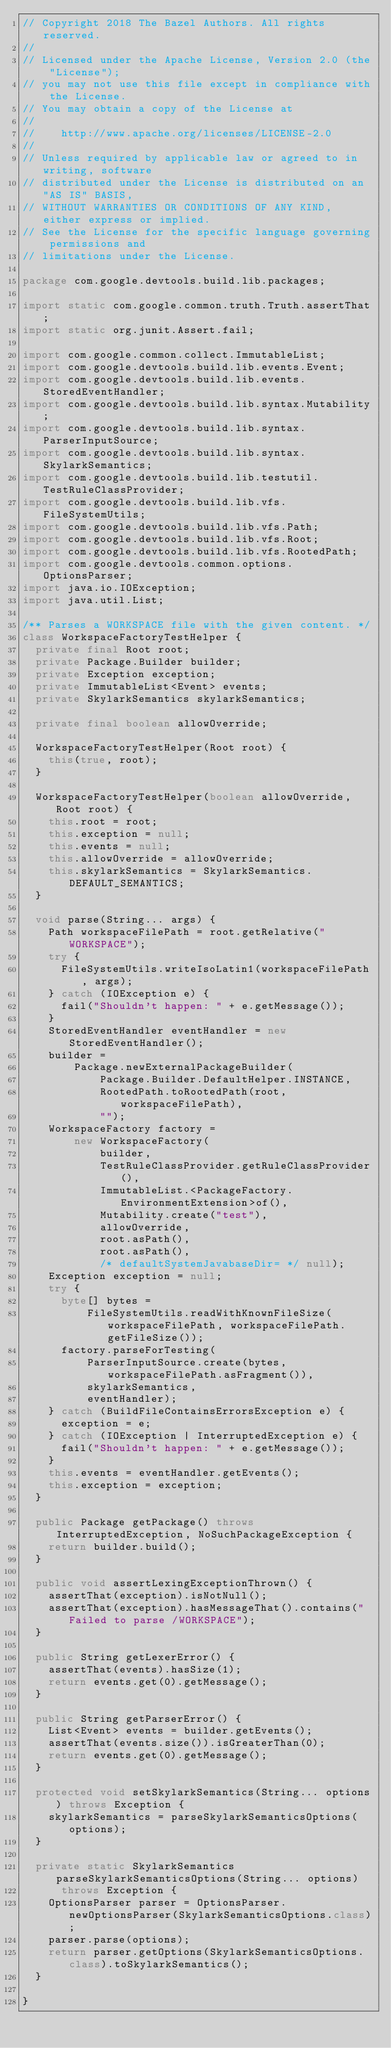<code> <loc_0><loc_0><loc_500><loc_500><_Java_>// Copyright 2018 The Bazel Authors. All rights reserved.
//
// Licensed under the Apache License, Version 2.0 (the "License");
// you may not use this file except in compliance with the License.
// You may obtain a copy of the License at
//
//    http://www.apache.org/licenses/LICENSE-2.0
//
// Unless required by applicable law or agreed to in writing, software
// distributed under the License is distributed on an "AS IS" BASIS,
// WITHOUT WARRANTIES OR CONDITIONS OF ANY KIND, either express or implied.
// See the License for the specific language governing permissions and
// limitations under the License.

package com.google.devtools.build.lib.packages;

import static com.google.common.truth.Truth.assertThat;
import static org.junit.Assert.fail;

import com.google.common.collect.ImmutableList;
import com.google.devtools.build.lib.events.Event;
import com.google.devtools.build.lib.events.StoredEventHandler;
import com.google.devtools.build.lib.syntax.Mutability;
import com.google.devtools.build.lib.syntax.ParserInputSource;
import com.google.devtools.build.lib.syntax.SkylarkSemantics;
import com.google.devtools.build.lib.testutil.TestRuleClassProvider;
import com.google.devtools.build.lib.vfs.FileSystemUtils;
import com.google.devtools.build.lib.vfs.Path;
import com.google.devtools.build.lib.vfs.Root;
import com.google.devtools.build.lib.vfs.RootedPath;
import com.google.devtools.common.options.OptionsParser;
import java.io.IOException;
import java.util.List;

/** Parses a WORKSPACE file with the given content. */
class WorkspaceFactoryTestHelper {
  private final Root root;
  private Package.Builder builder;
  private Exception exception;
  private ImmutableList<Event> events;
  private SkylarkSemantics skylarkSemantics;

  private final boolean allowOverride;

  WorkspaceFactoryTestHelper(Root root) {
    this(true, root);
  }

  WorkspaceFactoryTestHelper(boolean allowOverride, Root root) {
    this.root = root;
    this.exception = null;
    this.events = null;
    this.allowOverride = allowOverride;
    this.skylarkSemantics = SkylarkSemantics.DEFAULT_SEMANTICS;
  }

  void parse(String... args) {
    Path workspaceFilePath = root.getRelative("WORKSPACE");
    try {
      FileSystemUtils.writeIsoLatin1(workspaceFilePath, args);
    } catch (IOException e) {
      fail("Shouldn't happen: " + e.getMessage());
    }
    StoredEventHandler eventHandler = new StoredEventHandler();
    builder =
        Package.newExternalPackageBuilder(
            Package.Builder.DefaultHelper.INSTANCE,
            RootedPath.toRootedPath(root, workspaceFilePath),
            "");
    WorkspaceFactory factory =
        new WorkspaceFactory(
            builder,
            TestRuleClassProvider.getRuleClassProvider(),
            ImmutableList.<PackageFactory.EnvironmentExtension>of(),
            Mutability.create("test"),
            allowOverride,
            root.asPath(),
            root.asPath(),
            /* defaultSystemJavabaseDir= */ null);
    Exception exception = null;
    try {
      byte[] bytes =
          FileSystemUtils.readWithKnownFileSize(workspaceFilePath, workspaceFilePath.getFileSize());
      factory.parseForTesting(
          ParserInputSource.create(bytes, workspaceFilePath.asFragment()),
          skylarkSemantics,
          eventHandler);
    } catch (BuildFileContainsErrorsException e) {
      exception = e;
    } catch (IOException | InterruptedException e) {
      fail("Shouldn't happen: " + e.getMessage());
    }
    this.events = eventHandler.getEvents();
    this.exception = exception;
  }

  public Package getPackage() throws InterruptedException, NoSuchPackageException {
    return builder.build();
  }

  public void assertLexingExceptionThrown() {
    assertThat(exception).isNotNull();
    assertThat(exception).hasMessageThat().contains("Failed to parse /WORKSPACE");
  }

  public String getLexerError() {
    assertThat(events).hasSize(1);
    return events.get(0).getMessage();
  }

  public String getParserError() {
    List<Event> events = builder.getEvents();
    assertThat(events.size()).isGreaterThan(0);
    return events.get(0).getMessage();
  }

  protected void setSkylarkSemantics(String... options) throws Exception {
    skylarkSemantics = parseSkylarkSemanticsOptions(options);
  }

  private static SkylarkSemantics parseSkylarkSemanticsOptions(String... options)
      throws Exception {
    OptionsParser parser = OptionsParser.newOptionsParser(SkylarkSemanticsOptions.class);
    parser.parse(options);
    return parser.getOptions(SkylarkSemanticsOptions.class).toSkylarkSemantics();
  }

}
</code> 